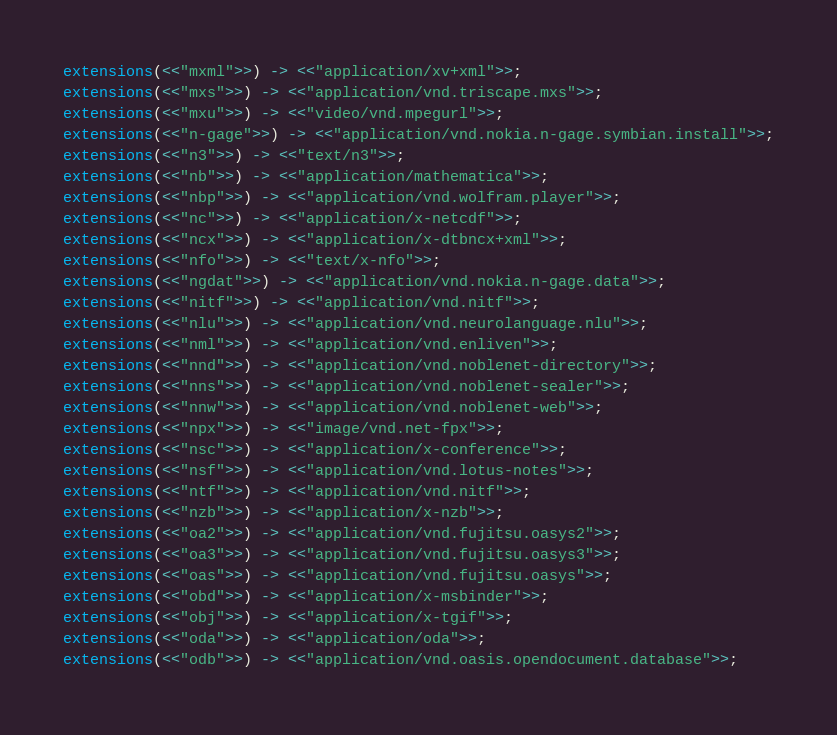Convert code to text. <code><loc_0><loc_0><loc_500><loc_500><_Erlang_>extensions(<<"mxml">>) -> <<"application/xv+xml">>;
extensions(<<"mxs">>) -> <<"application/vnd.triscape.mxs">>;
extensions(<<"mxu">>) -> <<"video/vnd.mpegurl">>;
extensions(<<"n-gage">>) -> <<"application/vnd.nokia.n-gage.symbian.install">>;
extensions(<<"n3">>) -> <<"text/n3">>;
extensions(<<"nb">>) -> <<"application/mathematica">>;
extensions(<<"nbp">>) -> <<"application/vnd.wolfram.player">>;
extensions(<<"nc">>) -> <<"application/x-netcdf">>;
extensions(<<"ncx">>) -> <<"application/x-dtbncx+xml">>;
extensions(<<"nfo">>) -> <<"text/x-nfo">>;
extensions(<<"ngdat">>) -> <<"application/vnd.nokia.n-gage.data">>;
extensions(<<"nitf">>) -> <<"application/vnd.nitf">>;
extensions(<<"nlu">>) -> <<"application/vnd.neurolanguage.nlu">>;
extensions(<<"nml">>) -> <<"application/vnd.enliven">>;
extensions(<<"nnd">>) -> <<"application/vnd.noblenet-directory">>;
extensions(<<"nns">>) -> <<"application/vnd.noblenet-sealer">>;
extensions(<<"nnw">>) -> <<"application/vnd.noblenet-web">>;
extensions(<<"npx">>) -> <<"image/vnd.net-fpx">>;
extensions(<<"nsc">>) -> <<"application/x-conference">>;
extensions(<<"nsf">>) -> <<"application/vnd.lotus-notes">>;
extensions(<<"ntf">>) -> <<"application/vnd.nitf">>;
extensions(<<"nzb">>) -> <<"application/x-nzb">>;
extensions(<<"oa2">>) -> <<"application/vnd.fujitsu.oasys2">>;
extensions(<<"oa3">>) -> <<"application/vnd.fujitsu.oasys3">>;
extensions(<<"oas">>) -> <<"application/vnd.fujitsu.oasys">>;
extensions(<<"obd">>) -> <<"application/x-msbinder">>;
extensions(<<"obj">>) -> <<"application/x-tgif">>;
extensions(<<"oda">>) -> <<"application/oda">>;
extensions(<<"odb">>) -> <<"application/vnd.oasis.opendocument.database">>;</code> 